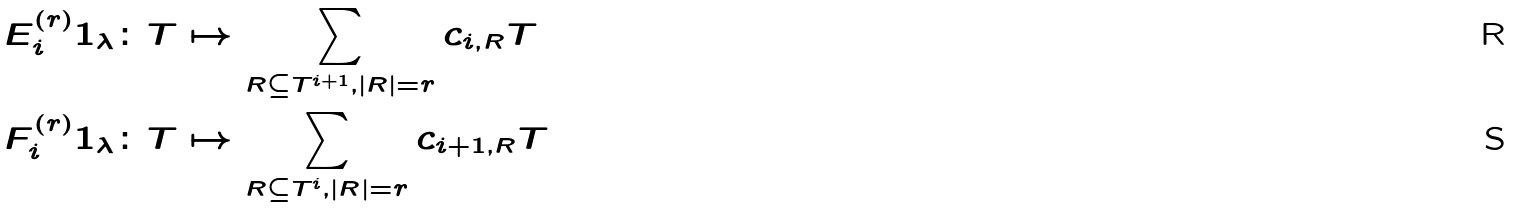Convert formula to latex. <formula><loc_0><loc_0><loc_500><loc_500>E ^ { ( r ) } _ { i } 1 _ { \lambda } & \colon T \mapsto \sum _ { R \subseteq T ^ { i + 1 } , | R | = r } c _ { i , R } T \\ F ^ { ( r ) } _ { i } 1 _ { \lambda } & \colon T \mapsto \sum _ { R \subseteq T ^ { i } , | R | = r } c _ { i + 1 , R } T</formula> 